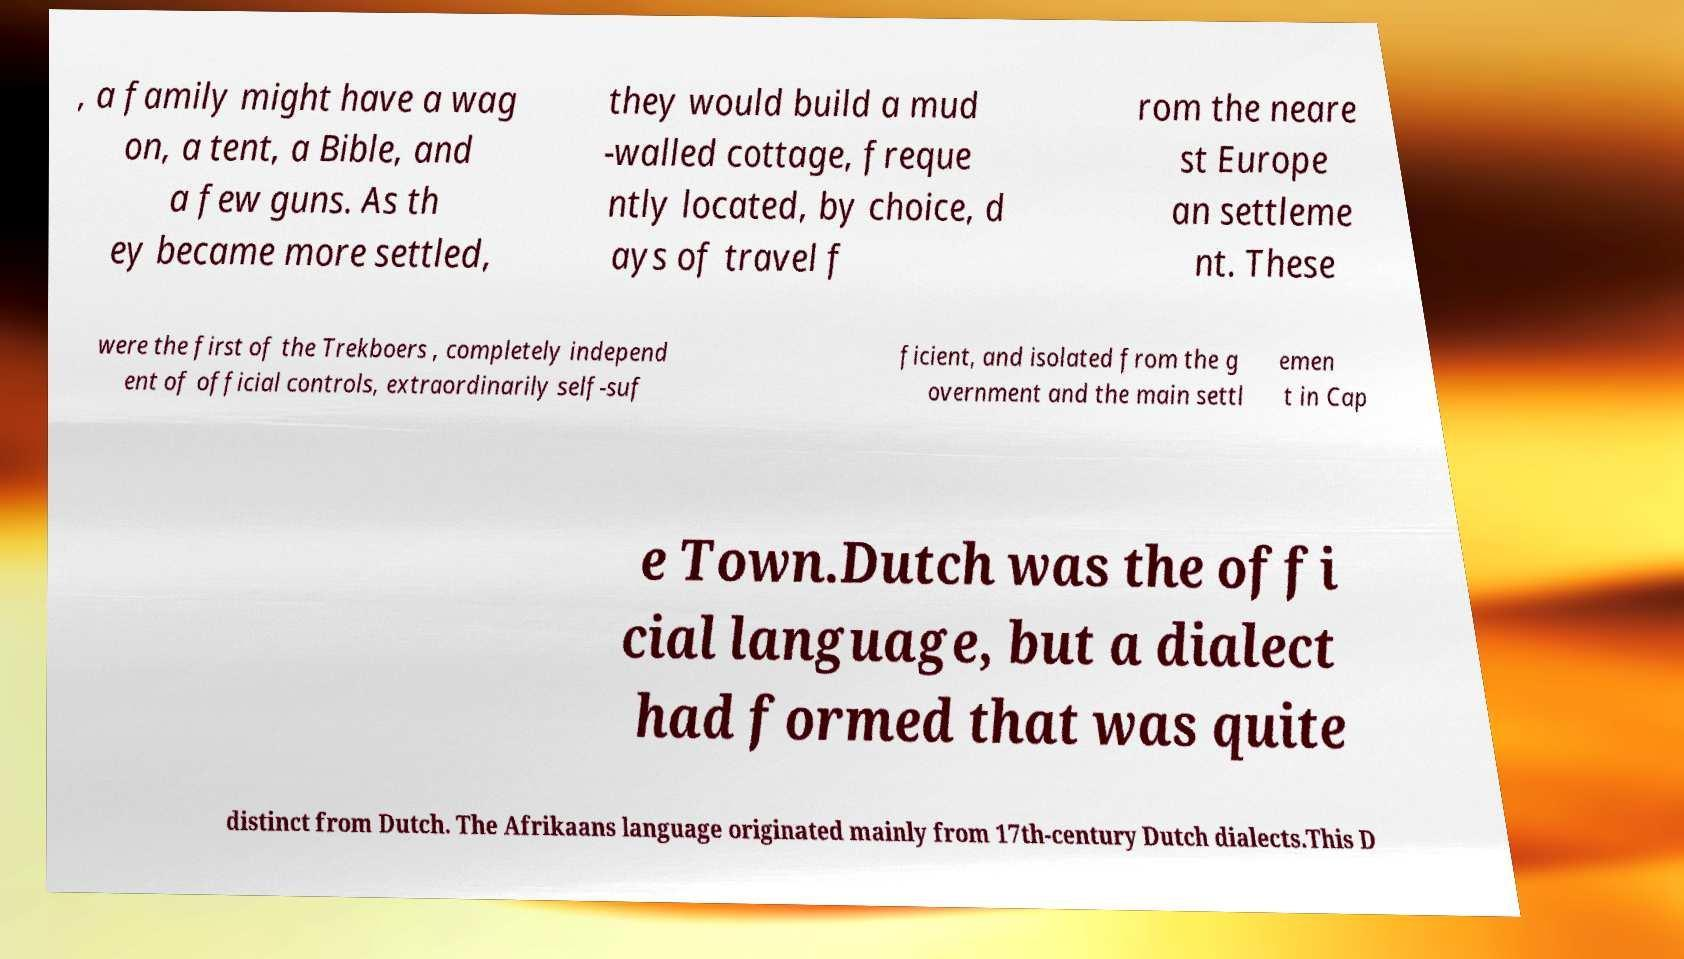I need the written content from this picture converted into text. Can you do that? , a family might have a wag on, a tent, a Bible, and a few guns. As th ey became more settled, they would build a mud -walled cottage, freque ntly located, by choice, d ays of travel f rom the neare st Europe an settleme nt. These were the first of the Trekboers , completely independ ent of official controls, extraordinarily self-suf ficient, and isolated from the g overnment and the main settl emen t in Cap e Town.Dutch was the offi cial language, but a dialect had formed that was quite distinct from Dutch. The Afrikaans language originated mainly from 17th-century Dutch dialects.This D 